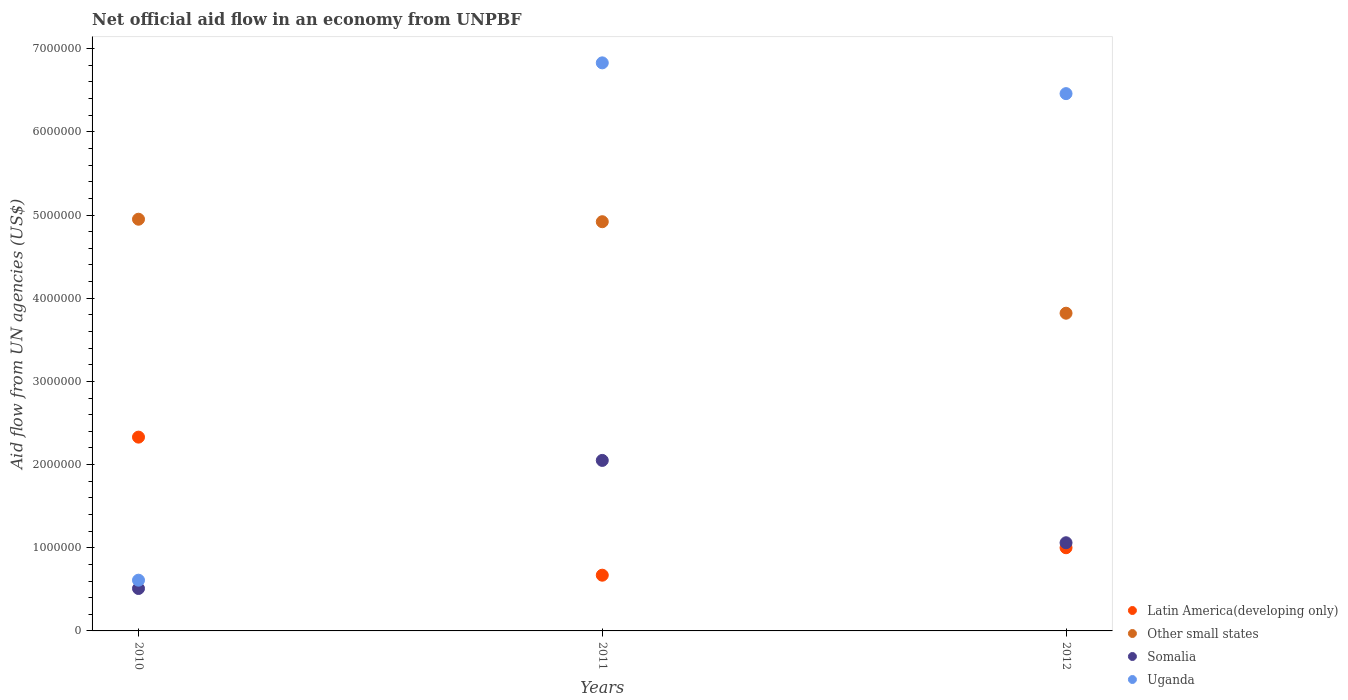Is the number of dotlines equal to the number of legend labels?
Offer a very short reply. Yes. What is the net official aid flow in Somalia in 2010?
Give a very brief answer. 5.10e+05. Across all years, what is the maximum net official aid flow in Other small states?
Your response must be concise. 4.95e+06. Across all years, what is the minimum net official aid flow in Somalia?
Your answer should be very brief. 5.10e+05. In which year was the net official aid flow in Other small states maximum?
Your response must be concise. 2010. In which year was the net official aid flow in Uganda minimum?
Provide a short and direct response. 2010. What is the total net official aid flow in Uganda in the graph?
Your response must be concise. 1.39e+07. What is the difference between the net official aid flow in Uganda in 2010 and that in 2011?
Provide a succinct answer. -6.22e+06. What is the average net official aid flow in Other small states per year?
Keep it short and to the point. 4.56e+06. In the year 2011, what is the difference between the net official aid flow in Uganda and net official aid flow in Latin America(developing only)?
Make the answer very short. 6.16e+06. What is the ratio of the net official aid flow in Other small states in 2011 to that in 2012?
Provide a succinct answer. 1.29. What is the difference between the highest and the lowest net official aid flow in Somalia?
Give a very brief answer. 1.54e+06. Does the net official aid flow in Other small states monotonically increase over the years?
Your answer should be very brief. No. Is the net official aid flow in Latin America(developing only) strictly less than the net official aid flow in Other small states over the years?
Your answer should be compact. Yes. What is the difference between two consecutive major ticks on the Y-axis?
Keep it short and to the point. 1.00e+06. Are the values on the major ticks of Y-axis written in scientific E-notation?
Your answer should be very brief. No. Does the graph contain grids?
Provide a succinct answer. No. Where does the legend appear in the graph?
Ensure brevity in your answer.  Bottom right. How are the legend labels stacked?
Keep it short and to the point. Vertical. What is the title of the graph?
Your answer should be very brief. Net official aid flow in an economy from UNPBF. What is the label or title of the Y-axis?
Offer a very short reply. Aid flow from UN agencies (US$). What is the Aid flow from UN agencies (US$) in Latin America(developing only) in 2010?
Your answer should be compact. 2.33e+06. What is the Aid flow from UN agencies (US$) of Other small states in 2010?
Ensure brevity in your answer.  4.95e+06. What is the Aid flow from UN agencies (US$) of Somalia in 2010?
Your answer should be very brief. 5.10e+05. What is the Aid flow from UN agencies (US$) in Uganda in 2010?
Your response must be concise. 6.10e+05. What is the Aid flow from UN agencies (US$) of Latin America(developing only) in 2011?
Provide a short and direct response. 6.70e+05. What is the Aid flow from UN agencies (US$) of Other small states in 2011?
Offer a terse response. 4.92e+06. What is the Aid flow from UN agencies (US$) of Somalia in 2011?
Your answer should be compact. 2.05e+06. What is the Aid flow from UN agencies (US$) in Uganda in 2011?
Give a very brief answer. 6.83e+06. What is the Aid flow from UN agencies (US$) of Latin America(developing only) in 2012?
Offer a terse response. 1.00e+06. What is the Aid flow from UN agencies (US$) of Other small states in 2012?
Provide a short and direct response. 3.82e+06. What is the Aid flow from UN agencies (US$) in Somalia in 2012?
Your response must be concise. 1.06e+06. What is the Aid flow from UN agencies (US$) in Uganda in 2012?
Keep it short and to the point. 6.46e+06. Across all years, what is the maximum Aid flow from UN agencies (US$) of Latin America(developing only)?
Your answer should be compact. 2.33e+06. Across all years, what is the maximum Aid flow from UN agencies (US$) of Other small states?
Ensure brevity in your answer.  4.95e+06. Across all years, what is the maximum Aid flow from UN agencies (US$) in Somalia?
Provide a succinct answer. 2.05e+06. Across all years, what is the maximum Aid flow from UN agencies (US$) of Uganda?
Your response must be concise. 6.83e+06. Across all years, what is the minimum Aid flow from UN agencies (US$) of Latin America(developing only)?
Give a very brief answer. 6.70e+05. Across all years, what is the minimum Aid flow from UN agencies (US$) in Other small states?
Provide a short and direct response. 3.82e+06. Across all years, what is the minimum Aid flow from UN agencies (US$) in Somalia?
Your response must be concise. 5.10e+05. What is the total Aid flow from UN agencies (US$) in Latin America(developing only) in the graph?
Give a very brief answer. 4.00e+06. What is the total Aid flow from UN agencies (US$) in Other small states in the graph?
Give a very brief answer. 1.37e+07. What is the total Aid flow from UN agencies (US$) in Somalia in the graph?
Offer a very short reply. 3.62e+06. What is the total Aid flow from UN agencies (US$) of Uganda in the graph?
Your answer should be compact. 1.39e+07. What is the difference between the Aid flow from UN agencies (US$) of Latin America(developing only) in 2010 and that in 2011?
Your answer should be compact. 1.66e+06. What is the difference between the Aid flow from UN agencies (US$) of Somalia in 2010 and that in 2011?
Give a very brief answer. -1.54e+06. What is the difference between the Aid flow from UN agencies (US$) in Uganda in 2010 and that in 2011?
Provide a short and direct response. -6.22e+06. What is the difference between the Aid flow from UN agencies (US$) in Latin America(developing only) in 2010 and that in 2012?
Provide a short and direct response. 1.33e+06. What is the difference between the Aid flow from UN agencies (US$) of Other small states in 2010 and that in 2012?
Your answer should be very brief. 1.13e+06. What is the difference between the Aid flow from UN agencies (US$) in Somalia in 2010 and that in 2012?
Your answer should be very brief. -5.50e+05. What is the difference between the Aid flow from UN agencies (US$) of Uganda in 2010 and that in 2012?
Offer a very short reply. -5.85e+06. What is the difference between the Aid flow from UN agencies (US$) of Latin America(developing only) in 2011 and that in 2012?
Provide a short and direct response. -3.30e+05. What is the difference between the Aid flow from UN agencies (US$) of Other small states in 2011 and that in 2012?
Make the answer very short. 1.10e+06. What is the difference between the Aid flow from UN agencies (US$) of Somalia in 2011 and that in 2012?
Provide a short and direct response. 9.90e+05. What is the difference between the Aid flow from UN agencies (US$) of Uganda in 2011 and that in 2012?
Keep it short and to the point. 3.70e+05. What is the difference between the Aid flow from UN agencies (US$) in Latin America(developing only) in 2010 and the Aid flow from UN agencies (US$) in Other small states in 2011?
Your answer should be compact. -2.59e+06. What is the difference between the Aid flow from UN agencies (US$) of Latin America(developing only) in 2010 and the Aid flow from UN agencies (US$) of Somalia in 2011?
Your response must be concise. 2.80e+05. What is the difference between the Aid flow from UN agencies (US$) of Latin America(developing only) in 2010 and the Aid flow from UN agencies (US$) of Uganda in 2011?
Ensure brevity in your answer.  -4.50e+06. What is the difference between the Aid flow from UN agencies (US$) of Other small states in 2010 and the Aid flow from UN agencies (US$) of Somalia in 2011?
Make the answer very short. 2.90e+06. What is the difference between the Aid flow from UN agencies (US$) of Other small states in 2010 and the Aid flow from UN agencies (US$) of Uganda in 2011?
Give a very brief answer. -1.88e+06. What is the difference between the Aid flow from UN agencies (US$) of Somalia in 2010 and the Aid flow from UN agencies (US$) of Uganda in 2011?
Ensure brevity in your answer.  -6.32e+06. What is the difference between the Aid flow from UN agencies (US$) in Latin America(developing only) in 2010 and the Aid flow from UN agencies (US$) in Other small states in 2012?
Offer a terse response. -1.49e+06. What is the difference between the Aid flow from UN agencies (US$) of Latin America(developing only) in 2010 and the Aid flow from UN agencies (US$) of Somalia in 2012?
Offer a terse response. 1.27e+06. What is the difference between the Aid flow from UN agencies (US$) in Latin America(developing only) in 2010 and the Aid flow from UN agencies (US$) in Uganda in 2012?
Your response must be concise. -4.13e+06. What is the difference between the Aid flow from UN agencies (US$) in Other small states in 2010 and the Aid flow from UN agencies (US$) in Somalia in 2012?
Offer a very short reply. 3.89e+06. What is the difference between the Aid flow from UN agencies (US$) in Other small states in 2010 and the Aid flow from UN agencies (US$) in Uganda in 2012?
Make the answer very short. -1.51e+06. What is the difference between the Aid flow from UN agencies (US$) of Somalia in 2010 and the Aid flow from UN agencies (US$) of Uganda in 2012?
Offer a terse response. -5.95e+06. What is the difference between the Aid flow from UN agencies (US$) of Latin America(developing only) in 2011 and the Aid flow from UN agencies (US$) of Other small states in 2012?
Make the answer very short. -3.15e+06. What is the difference between the Aid flow from UN agencies (US$) in Latin America(developing only) in 2011 and the Aid flow from UN agencies (US$) in Somalia in 2012?
Your answer should be compact. -3.90e+05. What is the difference between the Aid flow from UN agencies (US$) of Latin America(developing only) in 2011 and the Aid flow from UN agencies (US$) of Uganda in 2012?
Make the answer very short. -5.79e+06. What is the difference between the Aid flow from UN agencies (US$) of Other small states in 2011 and the Aid flow from UN agencies (US$) of Somalia in 2012?
Your answer should be very brief. 3.86e+06. What is the difference between the Aid flow from UN agencies (US$) in Other small states in 2011 and the Aid flow from UN agencies (US$) in Uganda in 2012?
Your answer should be very brief. -1.54e+06. What is the difference between the Aid flow from UN agencies (US$) in Somalia in 2011 and the Aid flow from UN agencies (US$) in Uganda in 2012?
Keep it short and to the point. -4.41e+06. What is the average Aid flow from UN agencies (US$) in Latin America(developing only) per year?
Keep it short and to the point. 1.33e+06. What is the average Aid flow from UN agencies (US$) in Other small states per year?
Give a very brief answer. 4.56e+06. What is the average Aid flow from UN agencies (US$) of Somalia per year?
Your answer should be compact. 1.21e+06. What is the average Aid flow from UN agencies (US$) of Uganda per year?
Ensure brevity in your answer.  4.63e+06. In the year 2010, what is the difference between the Aid flow from UN agencies (US$) in Latin America(developing only) and Aid flow from UN agencies (US$) in Other small states?
Provide a short and direct response. -2.62e+06. In the year 2010, what is the difference between the Aid flow from UN agencies (US$) of Latin America(developing only) and Aid flow from UN agencies (US$) of Somalia?
Provide a short and direct response. 1.82e+06. In the year 2010, what is the difference between the Aid flow from UN agencies (US$) of Latin America(developing only) and Aid flow from UN agencies (US$) of Uganda?
Your response must be concise. 1.72e+06. In the year 2010, what is the difference between the Aid flow from UN agencies (US$) in Other small states and Aid flow from UN agencies (US$) in Somalia?
Ensure brevity in your answer.  4.44e+06. In the year 2010, what is the difference between the Aid flow from UN agencies (US$) of Other small states and Aid flow from UN agencies (US$) of Uganda?
Your answer should be very brief. 4.34e+06. In the year 2010, what is the difference between the Aid flow from UN agencies (US$) in Somalia and Aid flow from UN agencies (US$) in Uganda?
Provide a short and direct response. -1.00e+05. In the year 2011, what is the difference between the Aid flow from UN agencies (US$) of Latin America(developing only) and Aid flow from UN agencies (US$) of Other small states?
Offer a very short reply. -4.25e+06. In the year 2011, what is the difference between the Aid flow from UN agencies (US$) in Latin America(developing only) and Aid flow from UN agencies (US$) in Somalia?
Provide a succinct answer. -1.38e+06. In the year 2011, what is the difference between the Aid flow from UN agencies (US$) of Latin America(developing only) and Aid flow from UN agencies (US$) of Uganda?
Make the answer very short. -6.16e+06. In the year 2011, what is the difference between the Aid flow from UN agencies (US$) of Other small states and Aid flow from UN agencies (US$) of Somalia?
Ensure brevity in your answer.  2.87e+06. In the year 2011, what is the difference between the Aid flow from UN agencies (US$) of Other small states and Aid flow from UN agencies (US$) of Uganda?
Provide a short and direct response. -1.91e+06. In the year 2011, what is the difference between the Aid flow from UN agencies (US$) in Somalia and Aid flow from UN agencies (US$) in Uganda?
Make the answer very short. -4.78e+06. In the year 2012, what is the difference between the Aid flow from UN agencies (US$) of Latin America(developing only) and Aid flow from UN agencies (US$) of Other small states?
Ensure brevity in your answer.  -2.82e+06. In the year 2012, what is the difference between the Aid flow from UN agencies (US$) of Latin America(developing only) and Aid flow from UN agencies (US$) of Somalia?
Make the answer very short. -6.00e+04. In the year 2012, what is the difference between the Aid flow from UN agencies (US$) in Latin America(developing only) and Aid flow from UN agencies (US$) in Uganda?
Offer a terse response. -5.46e+06. In the year 2012, what is the difference between the Aid flow from UN agencies (US$) of Other small states and Aid flow from UN agencies (US$) of Somalia?
Keep it short and to the point. 2.76e+06. In the year 2012, what is the difference between the Aid flow from UN agencies (US$) of Other small states and Aid flow from UN agencies (US$) of Uganda?
Your response must be concise. -2.64e+06. In the year 2012, what is the difference between the Aid flow from UN agencies (US$) of Somalia and Aid flow from UN agencies (US$) of Uganda?
Your response must be concise. -5.40e+06. What is the ratio of the Aid flow from UN agencies (US$) of Latin America(developing only) in 2010 to that in 2011?
Offer a very short reply. 3.48. What is the ratio of the Aid flow from UN agencies (US$) of Somalia in 2010 to that in 2011?
Offer a terse response. 0.25. What is the ratio of the Aid flow from UN agencies (US$) of Uganda in 2010 to that in 2011?
Your answer should be very brief. 0.09. What is the ratio of the Aid flow from UN agencies (US$) in Latin America(developing only) in 2010 to that in 2012?
Ensure brevity in your answer.  2.33. What is the ratio of the Aid flow from UN agencies (US$) of Other small states in 2010 to that in 2012?
Your answer should be very brief. 1.3. What is the ratio of the Aid flow from UN agencies (US$) of Somalia in 2010 to that in 2012?
Make the answer very short. 0.48. What is the ratio of the Aid flow from UN agencies (US$) of Uganda in 2010 to that in 2012?
Give a very brief answer. 0.09. What is the ratio of the Aid flow from UN agencies (US$) in Latin America(developing only) in 2011 to that in 2012?
Your answer should be compact. 0.67. What is the ratio of the Aid flow from UN agencies (US$) in Other small states in 2011 to that in 2012?
Keep it short and to the point. 1.29. What is the ratio of the Aid flow from UN agencies (US$) of Somalia in 2011 to that in 2012?
Your answer should be compact. 1.93. What is the ratio of the Aid flow from UN agencies (US$) in Uganda in 2011 to that in 2012?
Your answer should be compact. 1.06. What is the difference between the highest and the second highest Aid flow from UN agencies (US$) of Latin America(developing only)?
Your answer should be compact. 1.33e+06. What is the difference between the highest and the second highest Aid flow from UN agencies (US$) of Other small states?
Make the answer very short. 3.00e+04. What is the difference between the highest and the second highest Aid flow from UN agencies (US$) of Somalia?
Make the answer very short. 9.90e+05. What is the difference between the highest and the second highest Aid flow from UN agencies (US$) in Uganda?
Make the answer very short. 3.70e+05. What is the difference between the highest and the lowest Aid flow from UN agencies (US$) of Latin America(developing only)?
Provide a short and direct response. 1.66e+06. What is the difference between the highest and the lowest Aid flow from UN agencies (US$) in Other small states?
Your answer should be very brief. 1.13e+06. What is the difference between the highest and the lowest Aid flow from UN agencies (US$) in Somalia?
Ensure brevity in your answer.  1.54e+06. What is the difference between the highest and the lowest Aid flow from UN agencies (US$) of Uganda?
Your answer should be compact. 6.22e+06. 